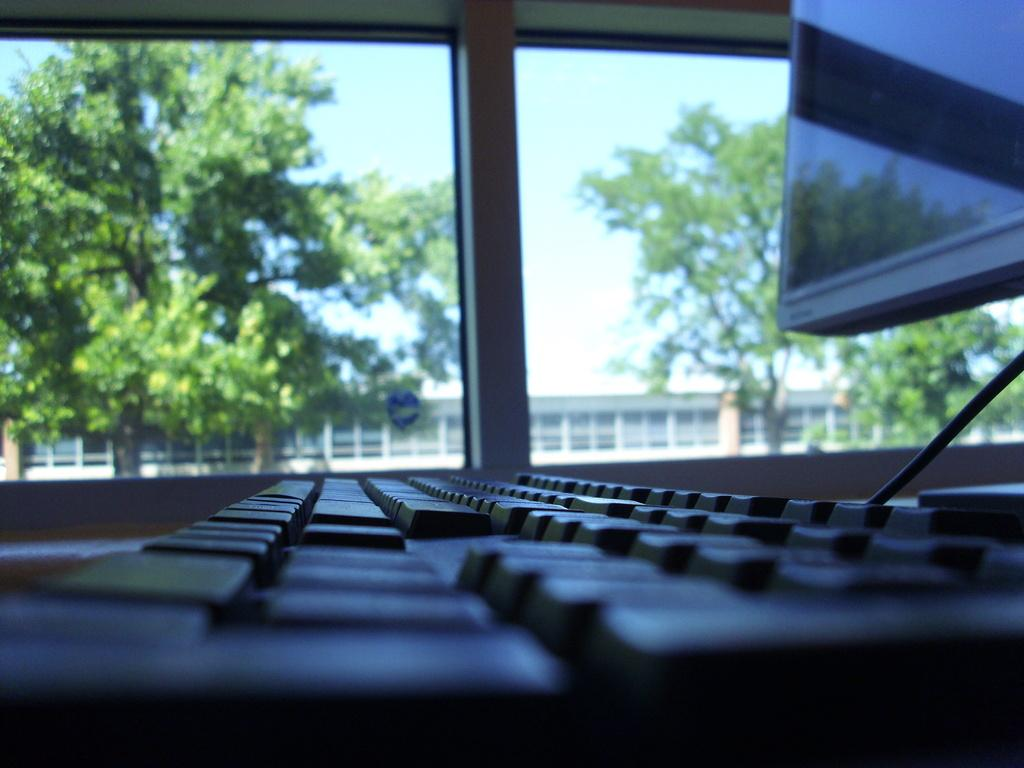What type of device is present in the image? There is a keypad and a monitor in the image. What can be seen through the window in the image? Trees are visible through the window in the image. What type of building is shown in the image? There is a house in the image. What is visible in the background of the image? The sky is visible in the image. How many pies are being baked in the oven in the image? There is no oven or pies present in the image. What type of pot is being used to cook the hot dish in the image? There is no pot or hot dish present in the image. 